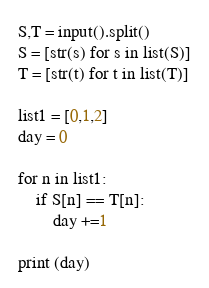Convert code to text. <code><loc_0><loc_0><loc_500><loc_500><_Python_>S,T = input().split()
S = [str(s) for s in list(S)]
T = [str(t) for t in list(T)]

list1 = [0,1,2]
day = 0

for n in list1:
    if S[n] == T[n]:
        day +=1

print (day)</code> 